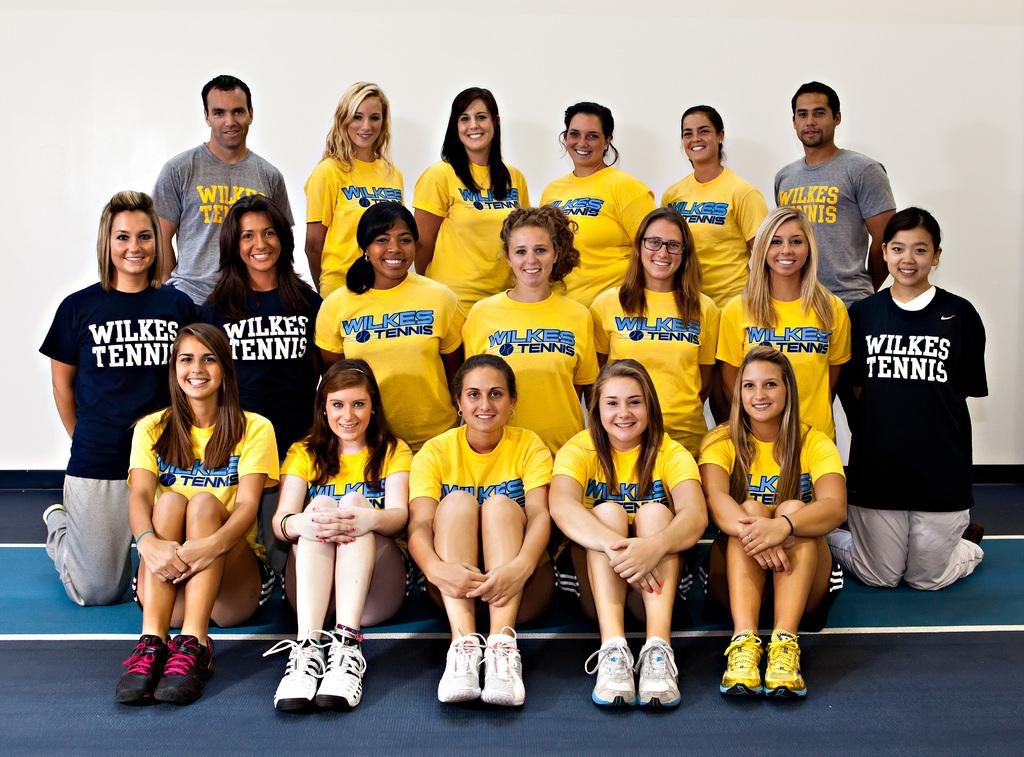Provide a one-sentence caption for the provided image. The Wilkes tennis team gathers for a team photo, both players and coaches. 